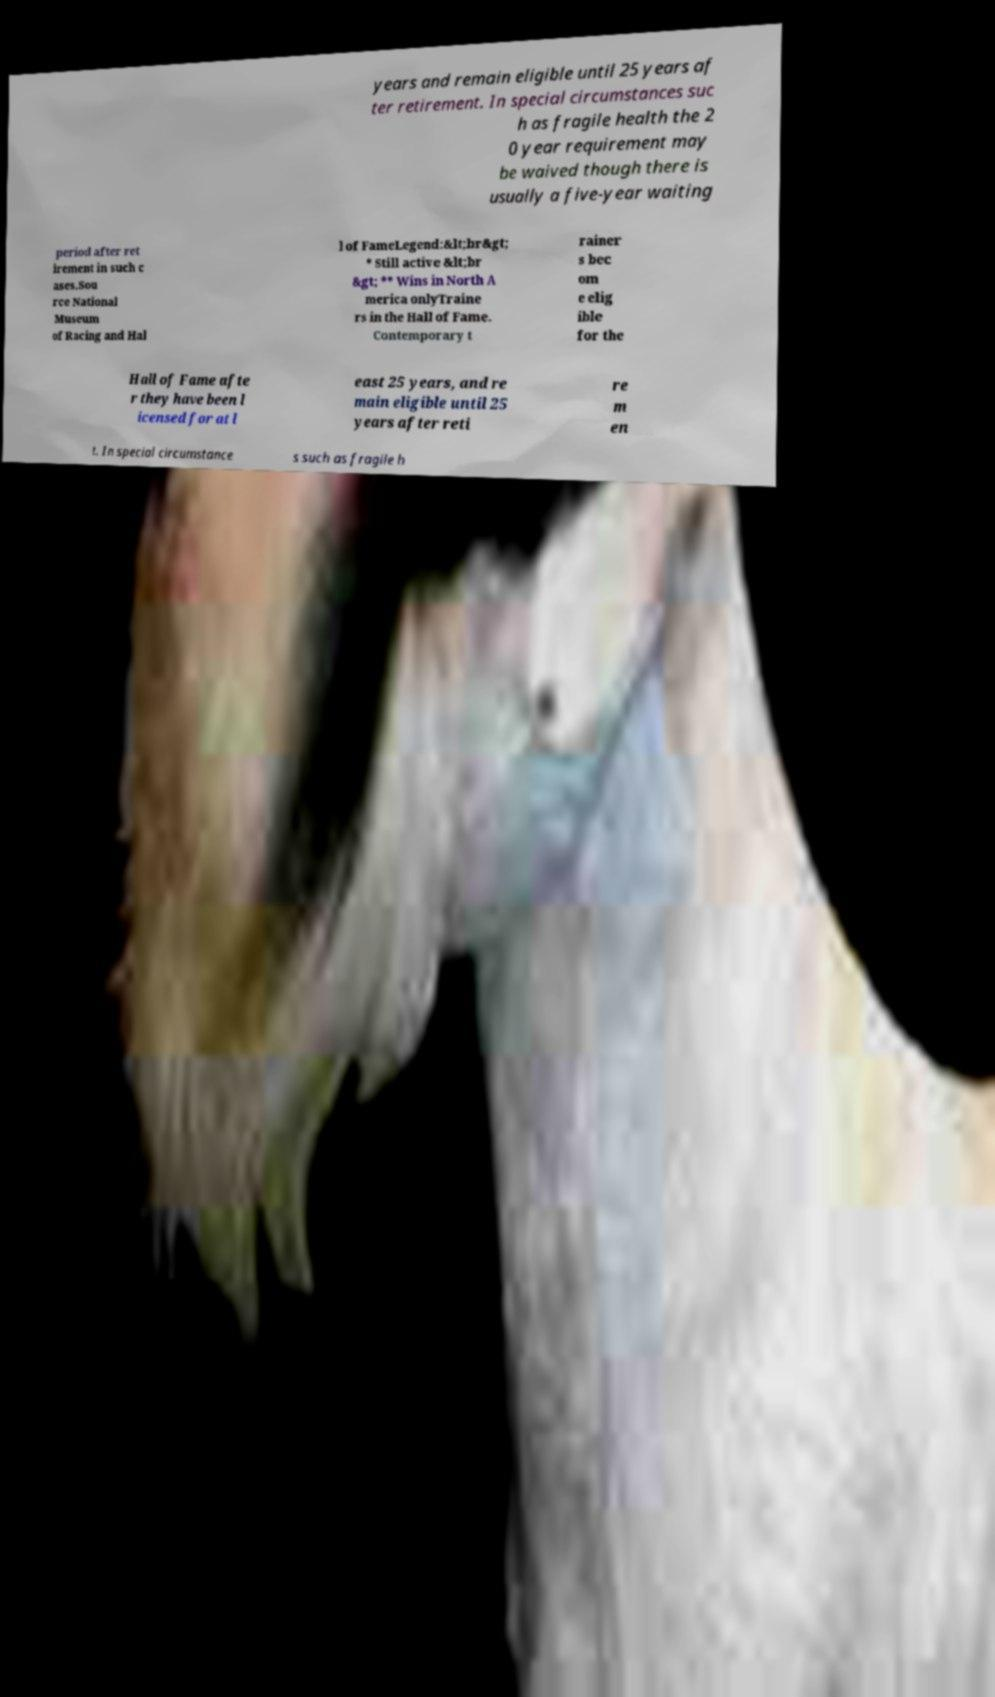Could you extract and type out the text from this image? years and remain eligible until 25 years af ter retirement. In special circumstances suc h as fragile health the 2 0 year requirement may be waived though there is usually a five-year waiting period after ret irement in such c ases.Sou rce National Museum of Racing and Hal l of FameLegend:&lt;br&gt; * Still active &lt;br &gt; ** Wins in North A merica onlyTraine rs in the Hall of Fame. Contemporary t rainer s bec om e elig ible for the Hall of Fame afte r they have been l icensed for at l east 25 years, and re main eligible until 25 years after reti re m en t. In special circumstance s such as fragile h 